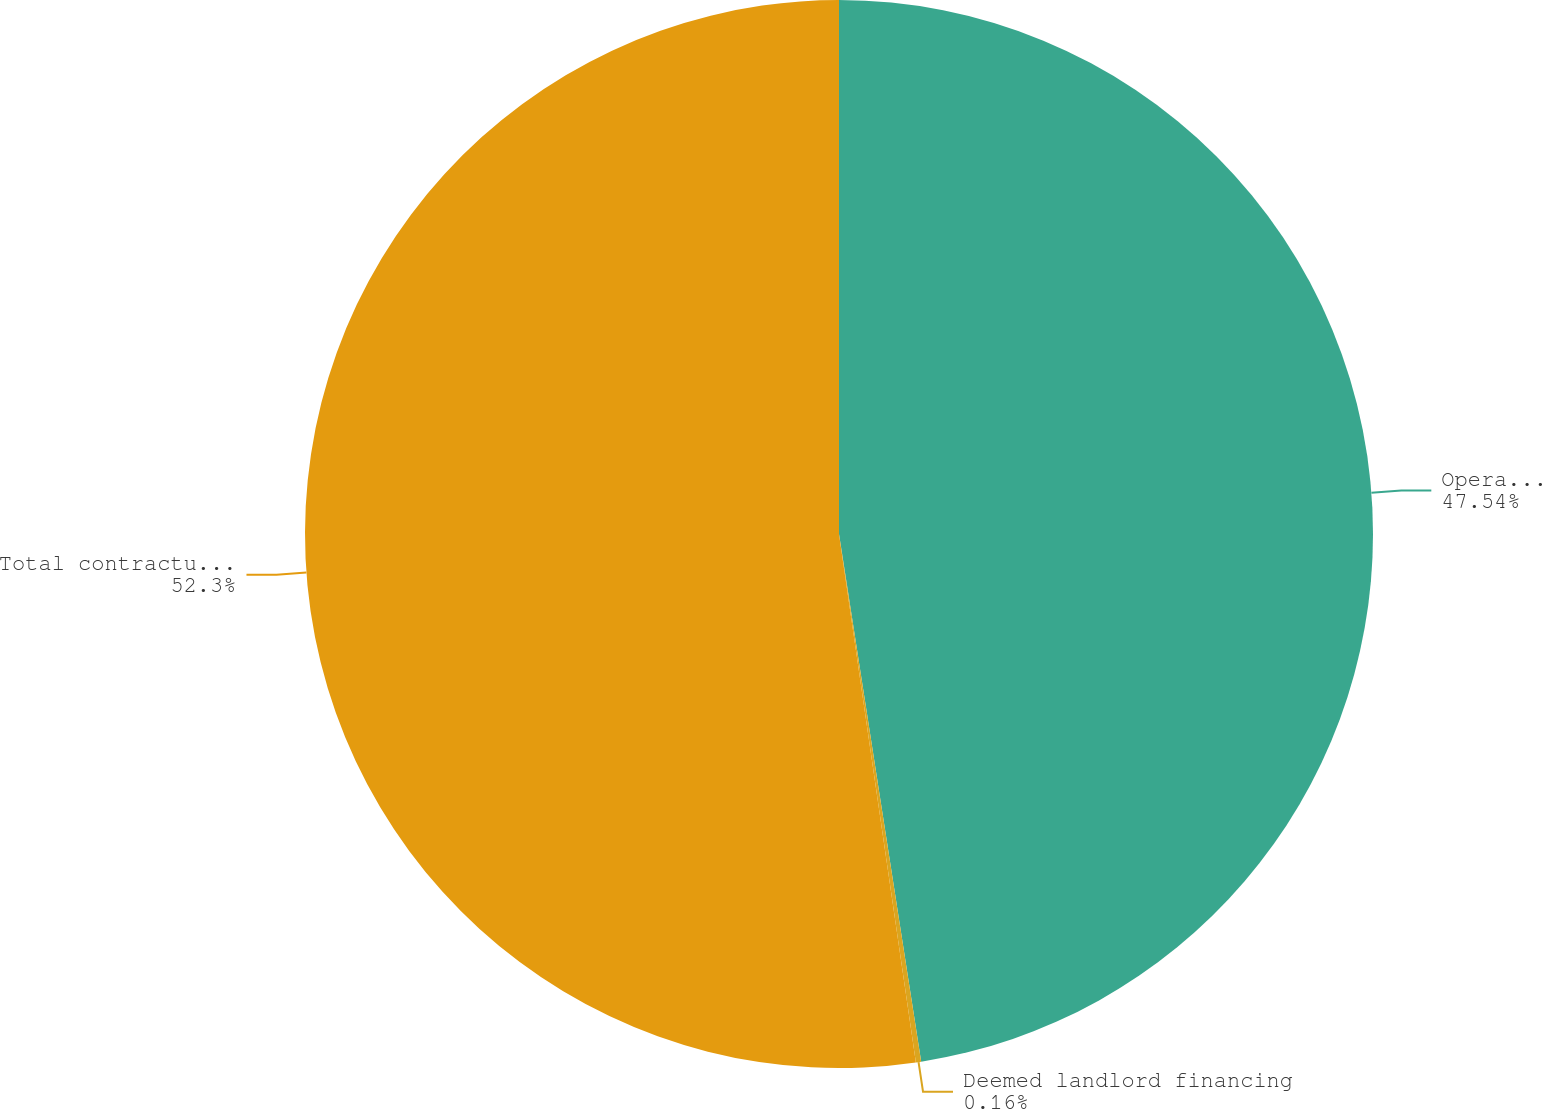<chart> <loc_0><loc_0><loc_500><loc_500><pie_chart><fcel>Operating leases<fcel>Deemed landlord financing<fcel>Total contractual cash<nl><fcel>47.54%<fcel>0.16%<fcel>52.3%<nl></chart> 